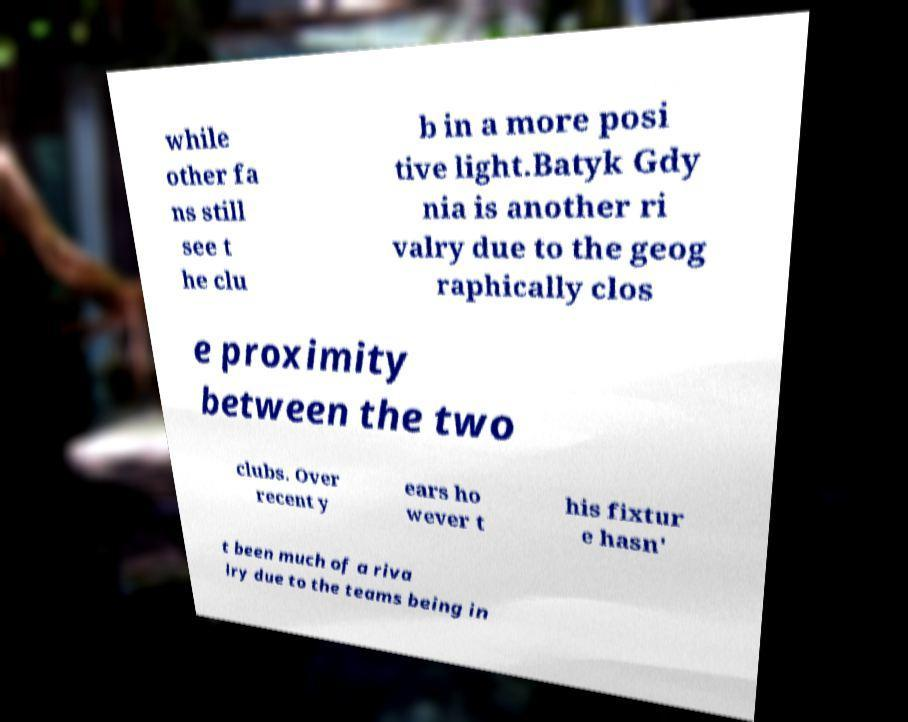Please identify and transcribe the text found in this image. while other fa ns still see t he clu b in a more posi tive light.Batyk Gdy nia is another ri valry due to the geog raphically clos e proximity between the two clubs. Over recent y ears ho wever t his fixtur e hasn' t been much of a riva lry due to the teams being in 